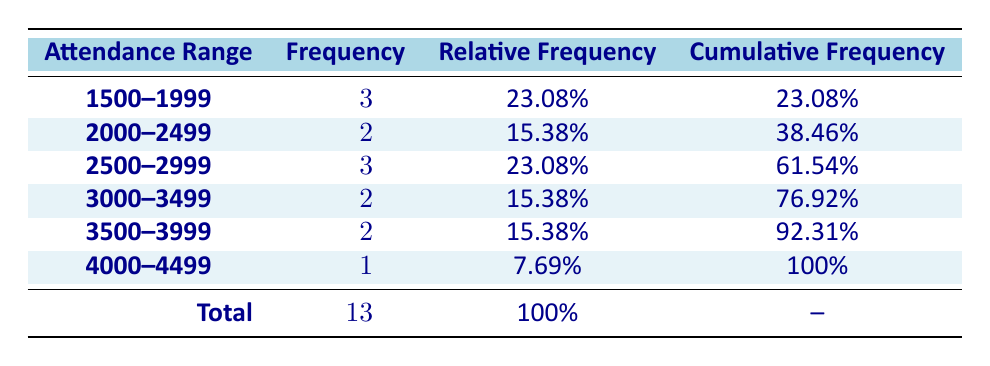What is the total attendance for matches with 4000 or more attendees? From the table, the matches that have an attendance of 4000 or more are Providence FC vs. New York Red Bulls II with 4000 and Providence FC vs. Louisville City FC with 4200, summing these gives 4000 + 4200 = 8200.
Answer: 8200 How many matches had attendance between 2000 and 2499? The table shows 2 matches within this attendance range: one with 2400 attendance (Boston Breakers vs. Rhode Island United) and one with 2500 attendance (Providence FC vs. New England United). Therefore, the frequency is 2.
Answer: 2 What percentage of matches had attendance below 3000? There are 5 matches below 3000 attendance: 1500, 1800, 2500, 2700, and 2100, out of a total of 13 matches. To find the percentage, 5/13 * 100 = approximately 38.46%.
Answer: 38.46% Are there any matches with an attendance of exactly 3500? Looking at the table, only the match Providence FC vs. Hartford Athletic has exactly 3500 attendees. Thus the answer is yes, there is one such match.
Answer: Yes Which attendance range has the highest frequency of matches? The most frequent attendance range is 1500–1999, with 3 matches listed (which is higher than any other range). Thus, this range clearly has the highest frequency.
Answer: 1500–1999 What is the cumulative frequency of matches with attendance from 3500 to 4499? To find this, we look at the cumulative frequencies: matches with attendance from 3500 to 3999 have a cumulative frequency of 92.31%, and the next range (4000–4499) adds another match, making the cumulative frequency 100%.
Answer: 100% How many matches had attendance between 3000 and 3499? The attendance ranges of 3000 to 3499 are covered by matches Providence FC vs. Hartford Athletic (3500) and Providence FC vs. Miami FC (3200). Only 2 matches fall into the 3000–3499 range.
Answer: 2 What is the relative frequency of matches with attendance in the range of 1500–1999? The relative frequency for the range of 1500–1999 is shown in the table as 23.08%. Therefore, this is a straightforward retrieval.
Answer: 23.08% How many matches were attended by less than 2000 people in total? The table lists 3 matches under the attendance range of 1500–1999, which corresponds exactly to the criteria. Therefore, the total count is 3.
Answer: 3 